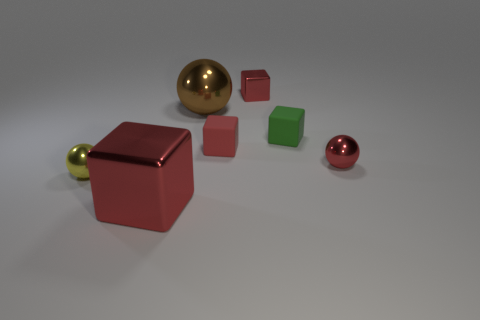Subtract all yellow cylinders. How many red cubes are left? 3 Subtract 2 cubes. How many cubes are left? 2 Subtract all yellow blocks. Subtract all gray cylinders. How many blocks are left? 4 Add 2 red metallic spheres. How many objects exist? 9 Subtract all spheres. How many objects are left? 4 Subtract all yellow metal things. Subtract all large red shiny cubes. How many objects are left? 5 Add 7 small red metallic blocks. How many small red metallic blocks are left? 8 Add 3 yellow shiny spheres. How many yellow shiny spheres exist? 4 Subtract 0 blue cylinders. How many objects are left? 7 